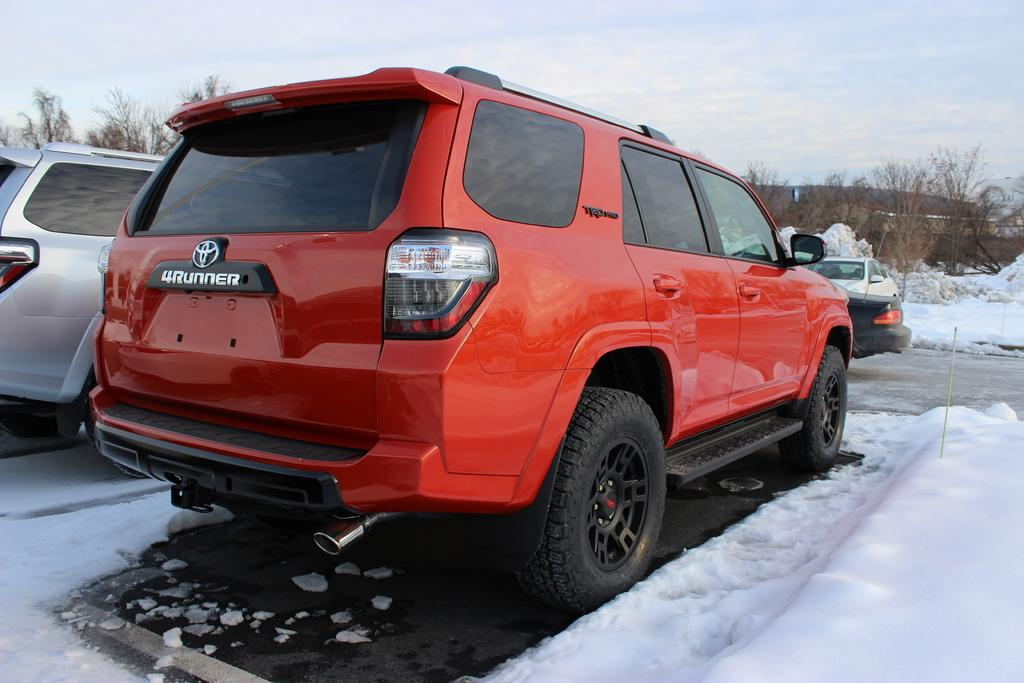What types of vehicles can be seen in the image? There are vehicles of different colors in the image. What is the weather like in the image? There is snow visible in the image, indicating a snowy or wintery scene. What type of natural environment is present in the image? There are trees in the image, suggesting a forest or wooded area. What is visible in the background of the image? The sky is visible in the image. What type of string is being used to hold up the sidewalk in the image? There is no sidewalk or string present in the image. What do people need to do in order to believe in the image? There is no belief system or concept being presented in the image; it simply depicts vehicles, snow, trees, and the sky. 